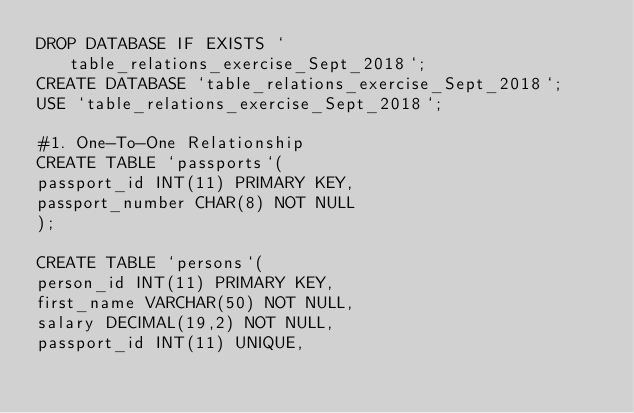Convert code to text. <code><loc_0><loc_0><loc_500><loc_500><_SQL_>DROP DATABASE IF EXISTS `table_relations_exercise_Sept_2018`;
CREATE DATABASE `table_relations_exercise_Sept_2018`;
USE `table_relations_exercise_Sept_2018`;

#1.	One-To-One Relationship
CREATE TABLE `passports`(
passport_id INT(11) PRIMARY KEY,
passport_number CHAR(8) NOT NULL
);

CREATE TABLE `persons`(
person_id INT(11) PRIMARY KEY,
first_name VARCHAR(50) NOT NULL,
salary DECIMAL(19,2) NOT NULL,
passport_id INT(11) UNIQUE,</code> 